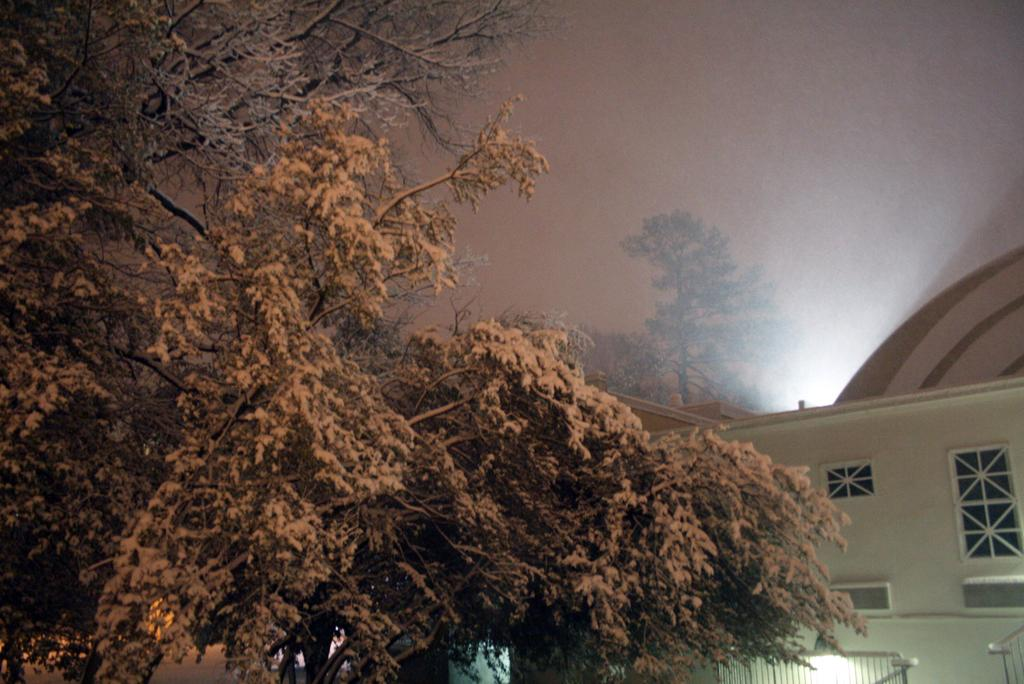What type of vegetation can be seen in the image? There are trees in the image. What type of structure is present in the image? There is a building in the image. What is visible in the background of the image? The sky is visible in the background of the image. What type of weather can be heard in the image? There is no sound or weather mentioned in the image, so it cannot be heard. 